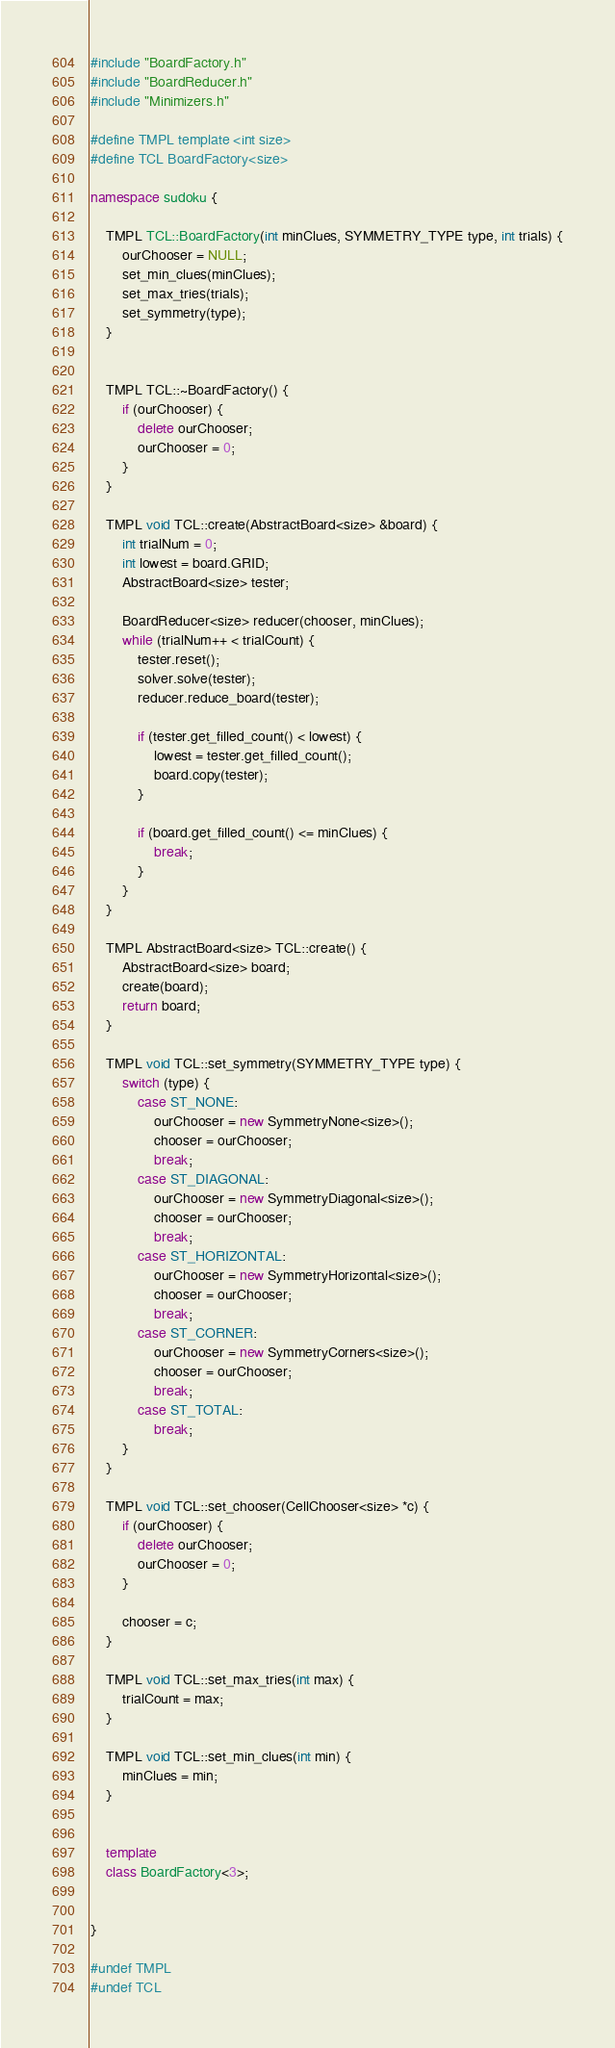Convert code to text. <code><loc_0><loc_0><loc_500><loc_500><_C++_>#include "BoardFactory.h"
#include "BoardReducer.h"
#include "Minimizers.h"

#define TMPL template <int size>
#define TCL BoardFactory<size>

namespace sudoku {

    TMPL TCL::BoardFactory(int minClues, SYMMETRY_TYPE type, int trials) {
        ourChooser = NULL;
        set_min_clues(minClues);
        set_max_tries(trials);
        set_symmetry(type);
    }


    TMPL TCL::~BoardFactory() {
        if (ourChooser) {
            delete ourChooser;
            ourChooser = 0;
        }
    }

    TMPL void TCL::create(AbstractBoard<size> &board) {
        int trialNum = 0;
        int lowest = board.GRID;
        AbstractBoard<size> tester;

        BoardReducer<size> reducer(chooser, minClues);
        while (trialNum++ < trialCount) {
            tester.reset();
            solver.solve(tester);
            reducer.reduce_board(tester);

            if (tester.get_filled_count() < lowest) {
                lowest = tester.get_filled_count();
                board.copy(tester);
            }

            if (board.get_filled_count() <= minClues) {
                break;
            }
        }
    }

    TMPL AbstractBoard<size> TCL::create() {
        AbstractBoard<size> board;
        create(board);
        return board;
    }

    TMPL void TCL::set_symmetry(SYMMETRY_TYPE type) {
        switch (type) {
            case ST_NONE:
                ourChooser = new SymmetryNone<size>();
                chooser = ourChooser;
                break;
            case ST_DIAGONAL:
                ourChooser = new SymmetryDiagonal<size>();
                chooser = ourChooser;
                break;
            case ST_HORIZONTAL:
                ourChooser = new SymmetryHorizontal<size>();
                chooser = ourChooser;
                break;
            case ST_CORNER:
                ourChooser = new SymmetryCorners<size>();
                chooser = ourChooser;
                break;
            case ST_TOTAL:
                break;
        }
    }

    TMPL void TCL::set_chooser(CellChooser<size> *c) {
        if (ourChooser) {
            delete ourChooser;
            ourChooser = 0;
        }

        chooser = c;
    }

    TMPL void TCL::set_max_tries(int max) {
        trialCount = max;
    }

    TMPL void TCL::set_min_clues(int min) {
        minClues = min;
    }


    template
    class BoardFactory<3>;


}

#undef TMPL
#undef TCL</code> 